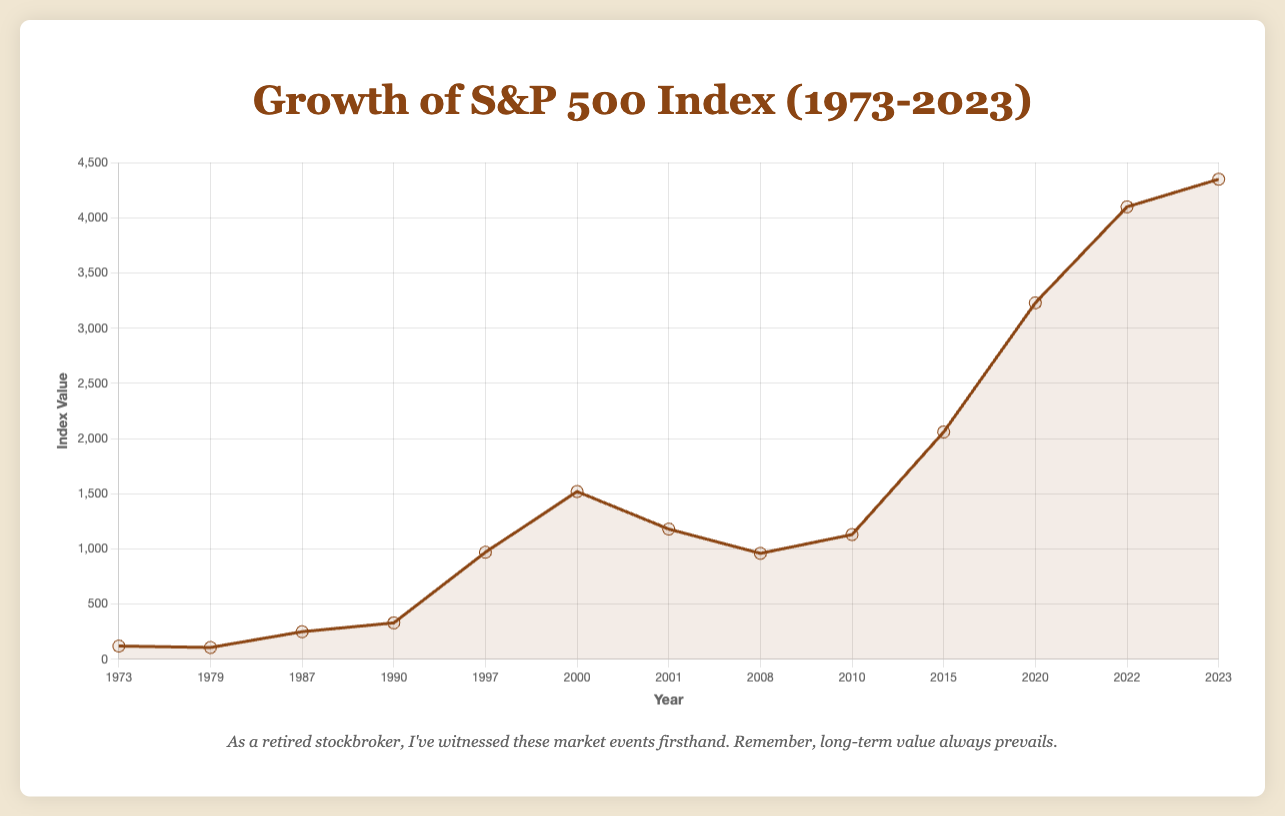What was the S&P 500 index value during the 1973 Oil Crisis, and how does it compare to its value in the 1979 Energy Crisis? The S&P 500 index value during the 1973 Oil Crisis was 120, and it fell to 107 by the time of the 1979 Energy Crisis. So, the index value decreased from 120 to 107 between these two crises.
Answer: The index value decreased from 120 to 107 What was the percentage increase in the S&P 500 index from the 2000 Dot-com Bubble to the value during the 2023 Post-Pandemic Recovery? The index value during the Dot-com Bubble in 2000 was 1520, and it increased to 4350 by 2023. The percentage increase can be calculated as ((4350 - 1520) / 1520) * 100. So, the percentage increase is ((2830) / 1520) * 100 ≈ 186.18%.
Answer: 186.18% What event had the S&P 500 index at its lowest value in the given data set, and what was that value? The index value was at its lowest during the 1979 Energy Crisis, with an index value of 107. This can be seen by comparing the index values around major events marked in the plot.
Answer: 107 during the 1979 Energy Crisis Comparing the S&P 500 index values during the Asian Financial Crisis (1997) and the Global Financial Crisis (2008), which value was higher and by how much? The index value during the Asian Financial Crisis in 1997 was 970, whereas during the Global Financial Crisis in 2008 it was 960. The Asian Financial Crisis's value was higher by (970 - 960) = 10 points.
Answer: 10 points higher during the Asian Financial Crisis What was the difference in the S&P 500 index values before and after the Global Financial Crisis of 2008? (Comparing 2008 and 2010) Before the Global Financial Crisis in 2008, the index value was 960. After the crisis in 2010, the index value rose to 1130. The difference between these values is (1130 - 960) = 170.
Answer: 170 points increase Comparing the visual highest index value points on the chart, identify the highest point and the corresponding event. The highest index value point on the chart is 4350, which corresponds to the Post-Pandemic Recovery in 2023. This can be observed as the peak value on the line chart.
Answer: 4350 during the Post-Pandemic Recovery What was the average value of the S&P 500 index between 1987's Black Monday Crash and 1997's Asian Financial Crisis? The index values for the specified years are 250 in 1987 and 970 in 1997. The average is calculated as (250 + 970) / 2 = 610.
Answer: 610 